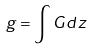<formula> <loc_0><loc_0><loc_500><loc_500>g = \int G d z</formula> 